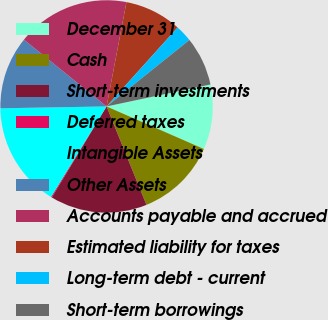<chart> <loc_0><loc_0><loc_500><loc_500><pie_chart><fcel>December 31<fcel>Cash<fcel>Short-term investments<fcel>Deferred taxes<fcel>Intangible Assets<fcel>Other Assets<fcel>Accounts payable and accrued<fcel>Estimated liability for taxes<fcel>Long-term debt - current<fcel>Short-term borrowings<nl><fcel>9.88%<fcel>12.31%<fcel>14.75%<fcel>0.14%<fcel>15.96%<fcel>11.1%<fcel>17.18%<fcel>8.66%<fcel>2.58%<fcel>7.44%<nl></chart> 